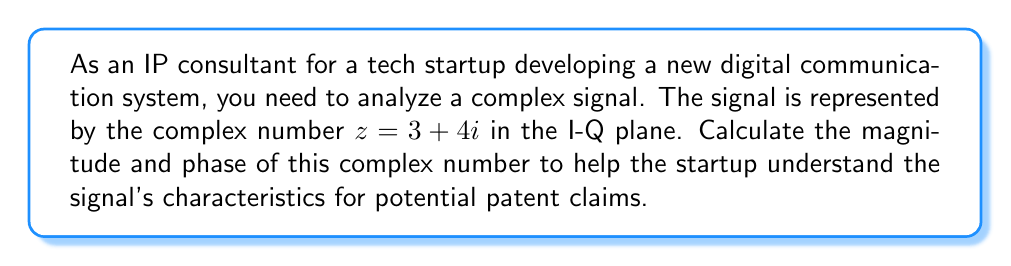Teach me how to tackle this problem. To calculate the magnitude and phase of a complex number $z = a + bi$, we use the following formulas:

1. Magnitude: $|z| = \sqrt{a^2 + b^2}$
2. Phase: $\theta = \tan^{-1}(\frac{b}{a})$

For the given complex number $z = 3 + 4i$:

1. Magnitude calculation:
   $$|z| = \sqrt{3^2 + 4^2} = \sqrt{9 + 16} = \sqrt{25} = 5$$

2. Phase calculation:
   $$\theta = \tan^{-1}(\frac{4}{3}) \approx 0.9273 \text{ radians}$$

   To convert radians to degrees, multiply by $\frac{180}{\pi}$:
   $$\theta \approx 0.9273 \times \frac{180}{\pi} \approx 53.13°$$

The magnitude represents the signal's amplitude, while the phase indicates its angular position in the I-Q plane. These characteristics are crucial for understanding the signal's properties in digital communication systems and can be valuable for patent claims related to signal processing and modulation techniques.
Answer: Magnitude: $|z| = 5$
Phase: $\theta \approx 0.9273 \text{ radians}$ or $\theta \approx 53.13°$ 